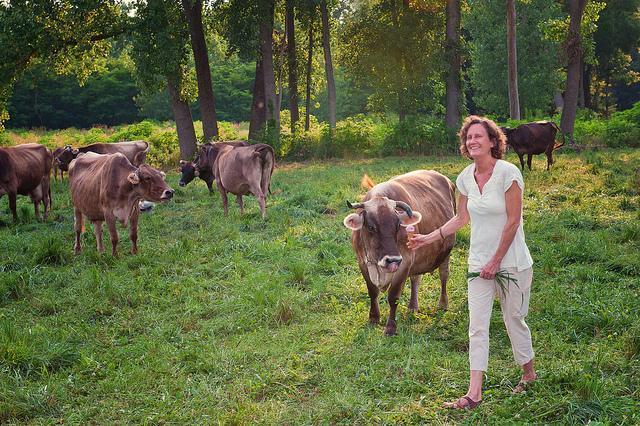How many people are in this picture?
Give a very brief answer. 1. How many cows are there?
Give a very brief answer. 4. 